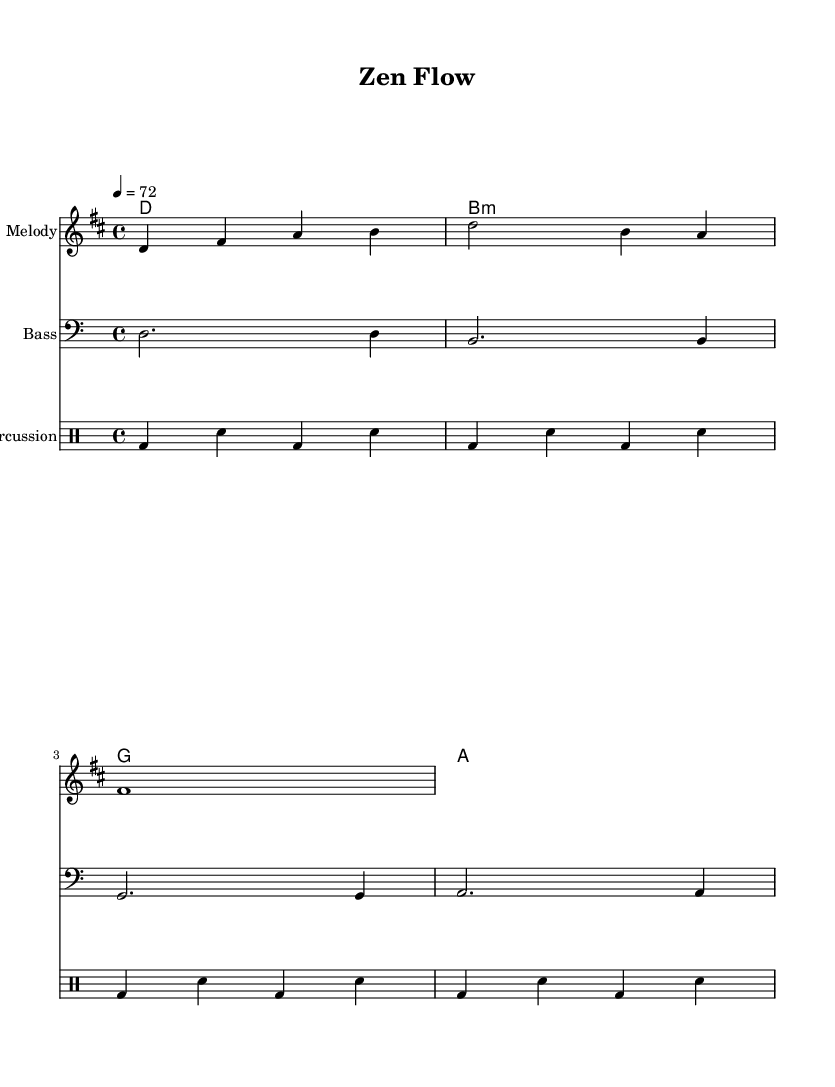What is the key signature of this music? The key signature indicated is D major, which has two sharps (F# and C#).
Answer: D major What is the tempo indicated for this piece? The tempo marking is given as 4 = 72, meaning there are 72 beats per minute in a 4/4 time.
Answer: 72 How many measures are there in the melody? The melody consists of four measures as shown by the repeated bar lines at the end of each line.
Answer: Four What is the first note of the melody? The first note in the melody is D, as indicated by the notation at the beginning of the melody staff.
Answer: D What is the chord progression shown in the harmony section? The chord progression is D, B minor, G, A, as outlined in the chord mode section.
Answer: D, B minor, G, A How does the bass line relate to the harmony? The bass line corresponds directly to the root notes of the harmony chords, reinforcing the harmonic structure.
Answer: Corresponds What type of percussion pattern is used in this piece? The percussion pattern consists of alternating bass drum and snare drum hits, creating a steady rhythm ideal for yoga practice.
Answer: Alternating bass and snare 